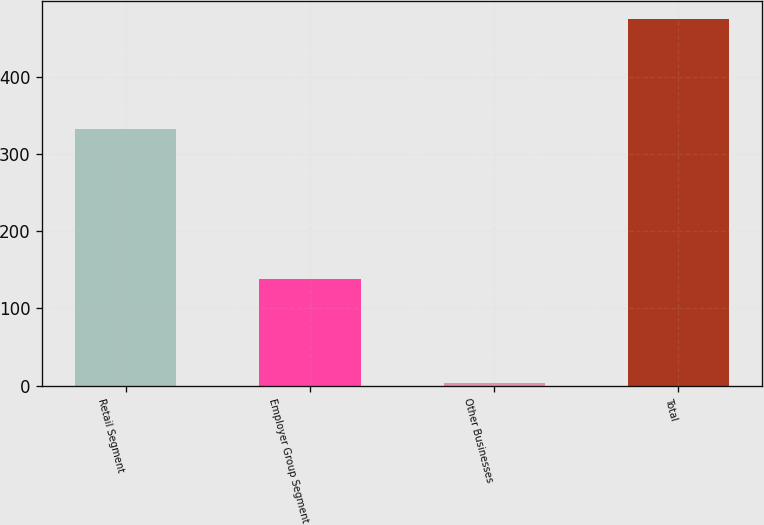Convert chart to OTSL. <chart><loc_0><loc_0><loc_500><loc_500><bar_chart><fcel>Retail Segment<fcel>Employer Group Segment<fcel>Other Businesses<fcel>Total<nl><fcel>332<fcel>138<fcel>4<fcel>474<nl></chart> 